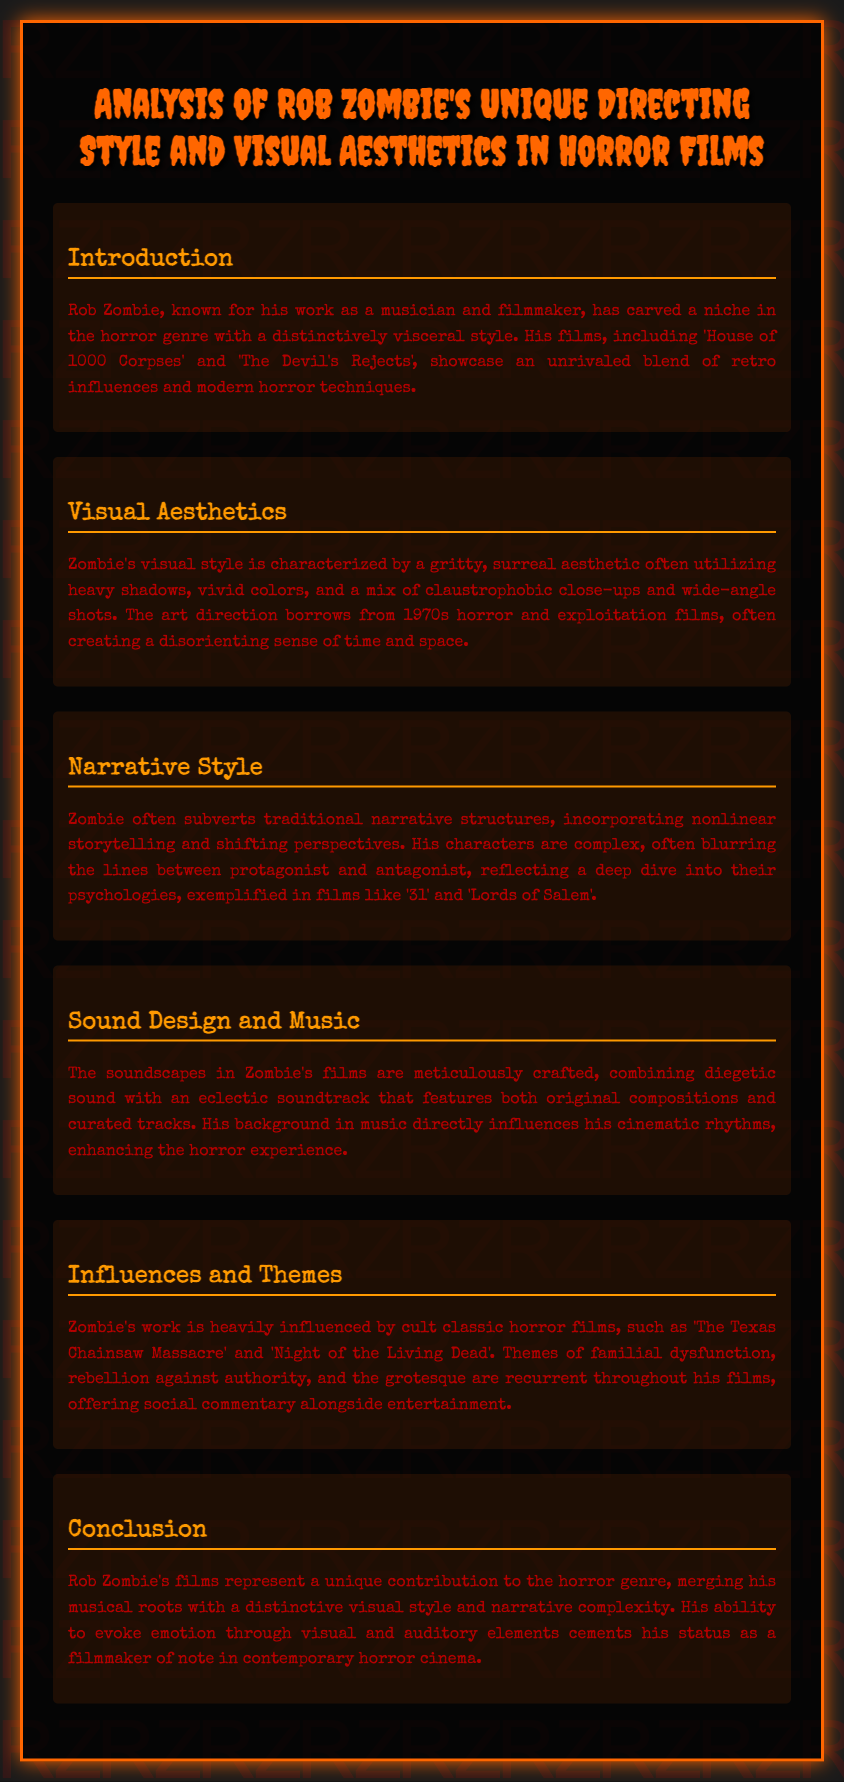What is Rob Zombie's primary genre of filmmaking? The document mentions that Rob Zombie has carved a niche in the horror genre.
Answer: horror Which film by Rob Zombie is mentioned first in the introduction? The introduction lists 'House of 1000 Corpses' as one of his notable films.
Answer: House of 1000 Corpses What decade's horror films heavily influence Zombie's visual style? The document states that Zombie's art direction borrows from 1970s horror and exploitation films.
Answer: 1970s What narrative technique does Rob Zombie often use in his films? The document explains that Zombie incorporates nonlinear storytelling in his narratives.
Answer: nonlinear storytelling Which two films exemplify complex characters in Zombie's films? The narrative style section highlights '31' and 'Lords of Salem' regarding character complexity.
Answer: 31, Lords of Salem What is a common theme in Rob Zombie's films? The document lists familial dysfunction as one of the recurrent themes.
Answer: familial dysfunction How does Zombie's background influence his films? The sound design section mentions that his background in music affects his cinematic rhythms.
Answer: music What type of soundscapes are used in Zombie's films? The document states that the soundscapes are meticulously crafted and combine diegetic sound with an eclectic soundtrack.
Answer: meticulously crafted What aspect of his films does Zombie merge with a unique visual style? The conclusion notes that Zombie merges his musical roots with a distinctive visual style in his films.
Answer: musical roots 